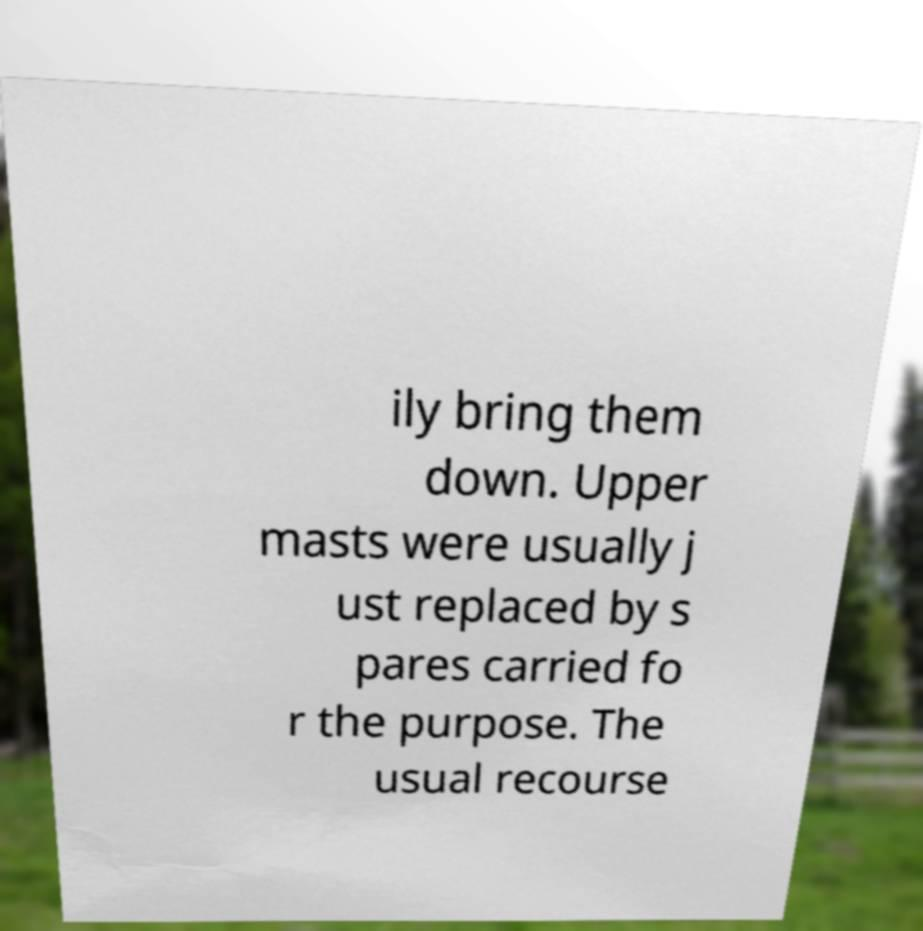What messages or text are displayed in this image? I need them in a readable, typed format. ily bring them down. Upper masts were usually j ust replaced by s pares carried fo r the purpose. The usual recourse 